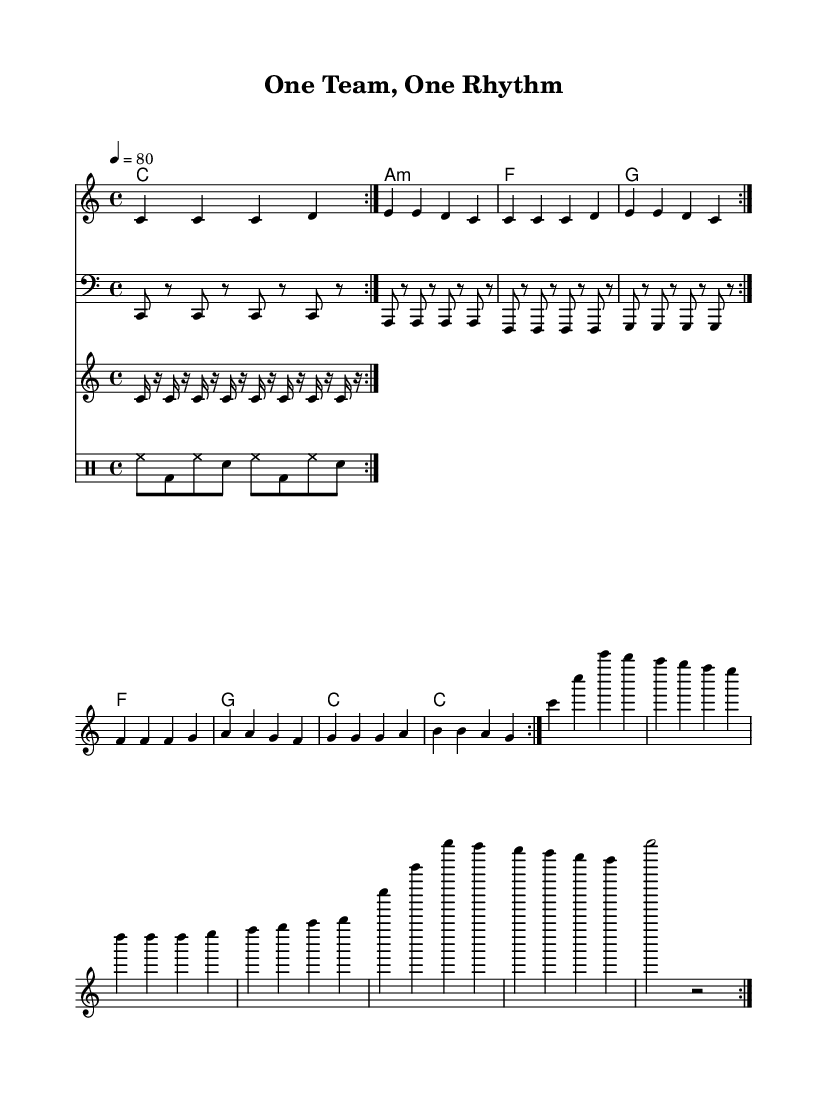What is the key signature of this music? The key signature is C major, indicated by no sharps or flats in the key signature section of the sheet music.
Answer: C major What is the time signature of the piece? The time signature is 4/4, shown at the beginning of the score, which indicates four beats per measure and a quarter note receives one beat.
Answer: 4/4 What is the tempo marking of the song? The tempo is marked at 80 beats per minute, as it is specified at the beginning of the score with the indication "4 = 80."
Answer: 80 How many times is the main melody repeated? The main melody is repeated two times, as denoted by "volta 2" in the melody section of the score.
Answer: 2 What type of guitar is featured in this piece? The guitar in this piece is a rhythm guitar, as indicated by the label "rhythm guitar" in the staff section that contains the chords.
Answer: rhythm guitar What musical genre does this piece represent? The piece represents reggae music, which is apparent from the title "One Team, One Rhythm" and the rhythmic patterns characteristic of reggae.
Answer: reggae How many measures are there in each repeated section? Each repeated section contains 8 measures, which can be counted by examining the melody that is grouped into two sections of 4 measures each.
Answer: 8 measures 